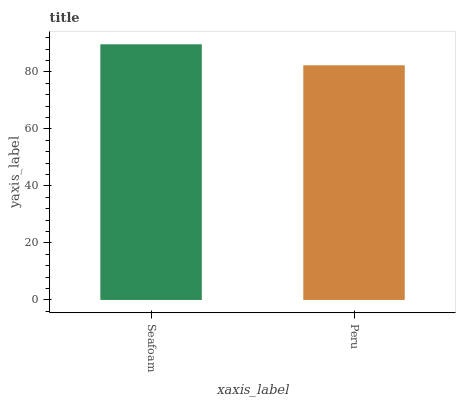Is Peru the minimum?
Answer yes or no. Yes. Is Seafoam the maximum?
Answer yes or no. Yes. Is Peru the maximum?
Answer yes or no. No. Is Seafoam greater than Peru?
Answer yes or no. Yes. Is Peru less than Seafoam?
Answer yes or no. Yes. Is Peru greater than Seafoam?
Answer yes or no. No. Is Seafoam less than Peru?
Answer yes or no. No. Is Seafoam the high median?
Answer yes or no. Yes. Is Peru the low median?
Answer yes or no. Yes. Is Peru the high median?
Answer yes or no. No. Is Seafoam the low median?
Answer yes or no. No. 